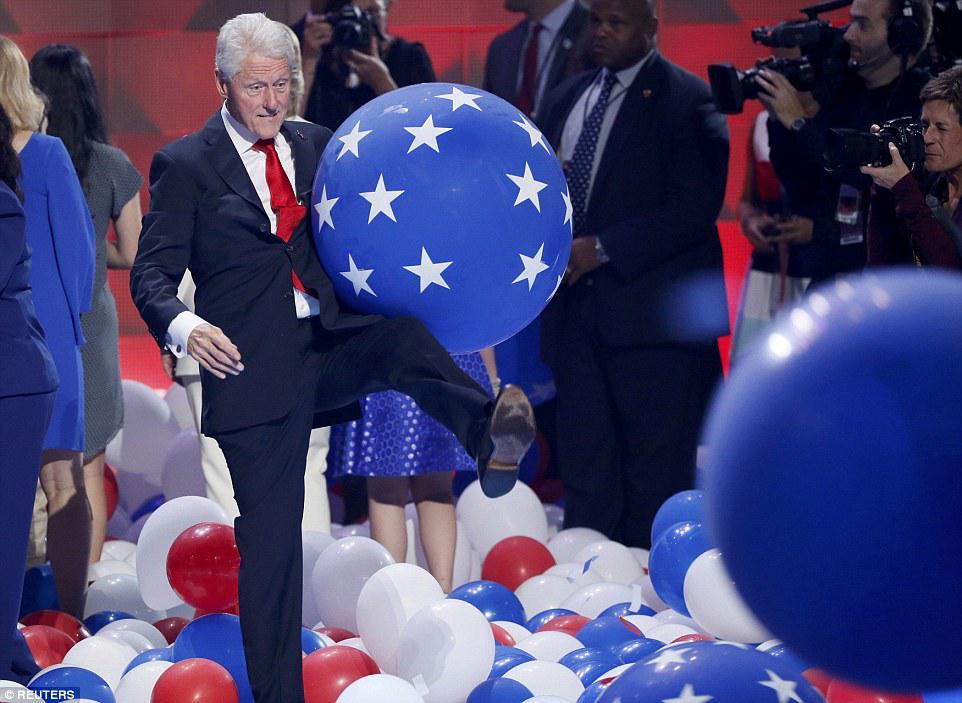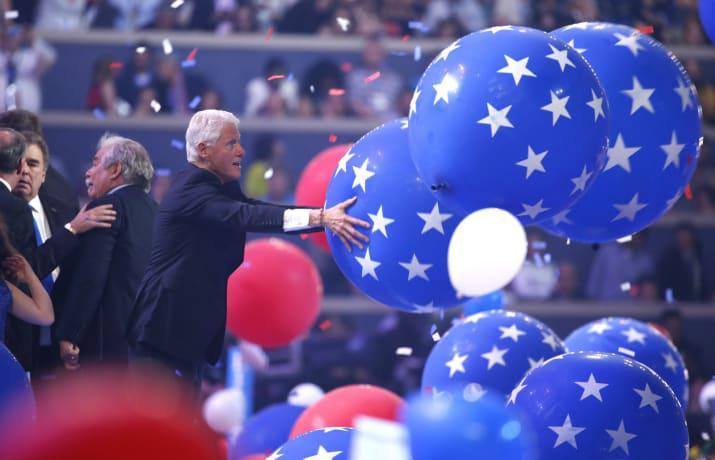The first image is the image on the left, the second image is the image on the right. Evaluate the accuracy of this statement regarding the images: "A white haired man is playing with red, white and blue balloons.". Is it true? Answer yes or no. Yes. The first image is the image on the left, the second image is the image on the right. Considering the images on both sides, is "In at least one image the president his holding a single blue balloon with stars." valid? Answer yes or no. Yes. 